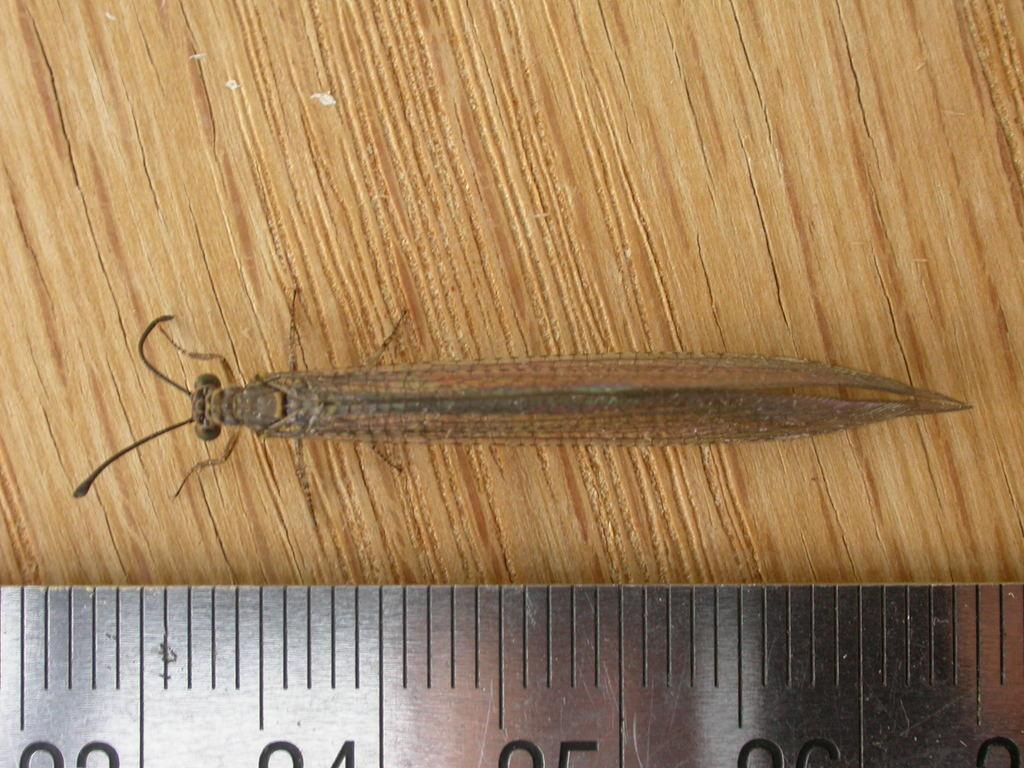What is the main object in the image? There is a measuring scale in the image. What else can be seen in the image besides the measuring scale? There is an insect in the image. Where is the insect located in the image? The insect is on a wooden platform. What type of connection is the insect making with the measuring scale in the image? There is no indication in the image that the insect is making any connection with the measuring scale. 